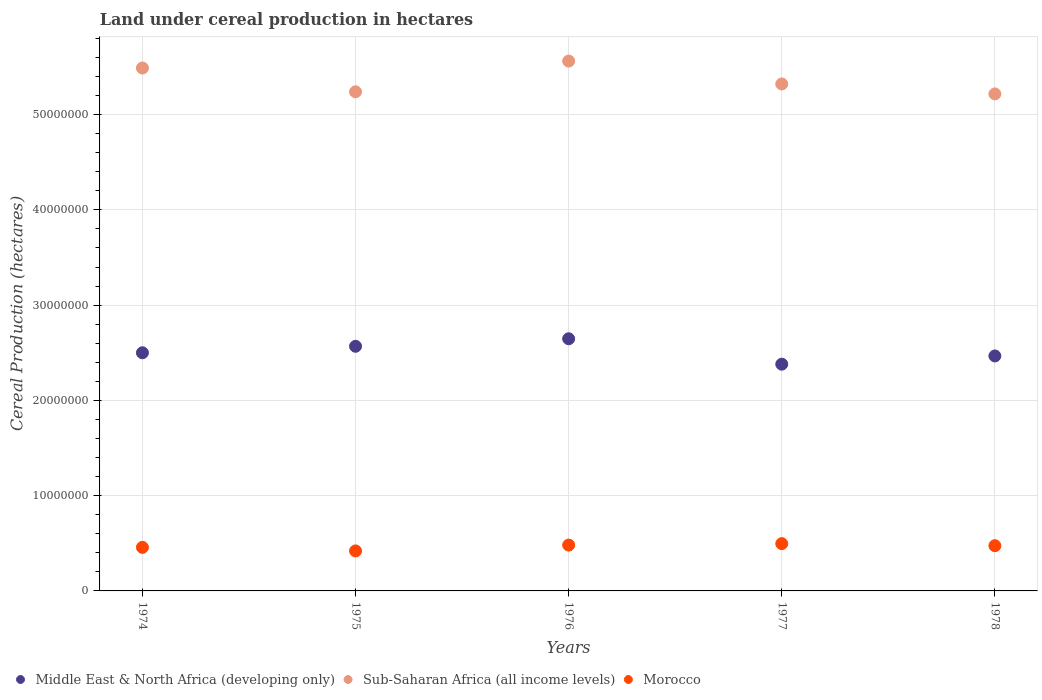What is the land under cereal production in Sub-Saharan Africa (all income levels) in 1975?
Offer a very short reply. 5.24e+07. Across all years, what is the maximum land under cereal production in Morocco?
Your answer should be very brief. 4.96e+06. Across all years, what is the minimum land under cereal production in Sub-Saharan Africa (all income levels)?
Your answer should be very brief. 5.22e+07. In which year was the land under cereal production in Morocco minimum?
Offer a very short reply. 1975. What is the total land under cereal production in Middle East & North Africa (developing only) in the graph?
Your answer should be very brief. 1.26e+08. What is the difference between the land under cereal production in Morocco in 1974 and that in 1978?
Ensure brevity in your answer.  -1.76e+05. What is the difference between the land under cereal production in Sub-Saharan Africa (all income levels) in 1978 and the land under cereal production in Middle East & North Africa (developing only) in 1977?
Give a very brief answer. 2.84e+07. What is the average land under cereal production in Morocco per year?
Offer a terse response. 4.66e+06. In the year 1978, what is the difference between the land under cereal production in Morocco and land under cereal production in Sub-Saharan Africa (all income levels)?
Provide a short and direct response. -4.74e+07. What is the ratio of the land under cereal production in Middle East & North Africa (developing only) in 1975 to that in 1976?
Your answer should be compact. 0.97. Is the land under cereal production in Morocco in 1975 less than that in 1977?
Keep it short and to the point. Yes. Is the difference between the land under cereal production in Morocco in 1976 and 1978 greater than the difference between the land under cereal production in Sub-Saharan Africa (all income levels) in 1976 and 1978?
Your answer should be compact. No. What is the difference between the highest and the second highest land under cereal production in Middle East & North Africa (developing only)?
Your response must be concise. 7.90e+05. What is the difference between the highest and the lowest land under cereal production in Morocco?
Give a very brief answer. 7.63e+05. Does the land under cereal production in Sub-Saharan Africa (all income levels) monotonically increase over the years?
Your response must be concise. No. Is the land under cereal production in Middle East & North Africa (developing only) strictly greater than the land under cereal production in Morocco over the years?
Make the answer very short. Yes. How many dotlines are there?
Provide a succinct answer. 3. What is the difference between two consecutive major ticks on the Y-axis?
Offer a terse response. 1.00e+07. Are the values on the major ticks of Y-axis written in scientific E-notation?
Offer a terse response. No. Where does the legend appear in the graph?
Your answer should be compact. Bottom left. How are the legend labels stacked?
Offer a terse response. Horizontal. What is the title of the graph?
Provide a succinct answer. Land under cereal production in hectares. Does "Korea (Republic)" appear as one of the legend labels in the graph?
Provide a short and direct response. No. What is the label or title of the Y-axis?
Your answer should be very brief. Cereal Production (hectares). What is the Cereal Production (hectares) of Middle East & North Africa (developing only) in 1974?
Provide a succinct answer. 2.50e+07. What is the Cereal Production (hectares) of Sub-Saharan Africa (all income levels) in 1974?
Provide a succinct answer. 5.49e+07. What is the Cereal Production (hectares) in Morocco in 1974?
Offer a very short reply. 4.57e+06. What is the Cereal Production (hectares) of Middle East & North Africa (developing only) in 1975?
Make the answer very short. 2.57e+07. What is the Cereal Production (hectares) of Sub-Saharan Africa (all income levels) in 1975?
Provide a succinct answer. 5.24e+07. What is the Cereal Production (hectares) of Morocco in 1975?
Your response must be concise. 4.20e+06. What is the Cereal Production (hectares) in Middle East & North Africa (developing only) in 1976?
Provide a short and direct response. 2.65e+07. What is the Cereal Production (hectares) in Sub-Saharan Africa (all income levels) in 1976?
Ensure brevity in your answer.  5.56e+07. What is the Cereal Production (hectares) in Morocco in 1976?
Your answer should be very brief. 4.81e+06. What is the Cereal Production (hectares) in Middle East & North Africa (developing only) in 1977?
Provide a succinct answer. 2.38e+07. What is the Cereal Production (hectares) of Sub-Saharan Africa (all income levels) in 1977?
Provide a short and direct response. 5.32e+07. What is the Cereal Production (hectares) in Morocco in 1977?
Keep it short and to the point. 4.96e+06. What is the Cereal Production (hectares) in Middle East & North Africa (developing only) in 1978?
Provide a short and direct response. 2.47e+07. What is the Cereal Production (hectares) in Sub-Saharan Africa (all income levels) in 1978?
Ensure brevity in your answer.  5.22e+07. What is the Cereal Production (hectares) of Morocco in 1978?
Offer a very short reply. 4.75e+06. Across all years, what is the maximum Cereal Production (hectares) of Middle East & North Africa (developing only)?
Offer a terse response. 2.65e+07. Across all years, what is the maximum Cereal Production (hectares) of Sub-Saharan Africa (all income levels)?
Give a very brief answer. 5.56e+07. Across all years, what is the maximum Cereal Production (hectares) of Morocco?
Provide a short and direct response. 4.96e+06. Across all years, what is the minimum Cereal Production (hectares) in Middle East & North Africa (developing only)?
Offer a terse response. 2.38e+07. Across all years, what is the minimum Cereal Production (hectares) in Sub-Saharan Africa (all income levels)?
Your answer should be very brief. 5.22e+07. Across all years, what is the minimum Cereal Production (hectares) of Morocco?
Your answer should be very brief. 4.20e+06. What is the total Cereal Production (hectares) in Middle East & North Africa (developing only) in the graph?
Your answer should be compact. 1.26e+08. What is the total Cereal Production (hectares) of Sub-Saharan Africa (all income levels) in the graph?
Keep it short and to the point. 2.68e+08. What is the total Cereal Production (hectares) of Morocco in the graph?
Your response must be concise. 2.33e+07. What is the difference between the Cereal Production (hectares) of Middle East & North Africa (developing only) in 1974 and that in 1975?
Your response must be concise. -6.79e+05. What is the difference between the Cereal Production (hectares) of Sub-Saharan Africa (all income levels) in 1974 and that in 1975?
Provide a short and direct response. 2.50e+06. What is the difference between the Cereal Production (hectares) in Morocco in 1974 and that in 1975?
Provide a succinct answer. 3.72e+05. What is the difference between the Cereal Production (hectares) of Middle East & North Africa (developing only) in 1974 and that in 1976?
Your response must be concise. -1.47e+06. What is the difference between the Cereal Production (hectares) in Sub-Saharan Africa (all income levels) in 1974 and that in 1976?
Make the answer very short. -7.29e+05. What is the difference between the Cereal Production (hectares) of Morocco in 1974 and that in 1976?
Provide a succinct answer. -2.40e+05. What is the difference between the Cereal Production (hectares) of Middle East & North Africa (developing only) in 1974 and that in 1977?
Your response must be concise. 1.20e+06. What is the difference between the Cereal Production (hectares) of Sub-Saharan Africa (all income levels) in 1974 and that in 1977?
Ensure brevity in your answer.  1.67e+06. What is the difference between the Cereal Production (hectares) in Morocco in 1974 and that in 1977?
Provide a short and direct response. -3.91e+05. What is the difference between the Cereal Production (hectares) in Middle East & North Africa (developing only) in 1974 and that in 1978?
Your answer should be very brief. 3.34e+05. What is the difference between the Cereal Production (hectares) of Sub-Saharan Africa (all income levels) in 1974 and that in 1978?
Offer a very short reply. 2.72e+06. What is the difference between the Cereal Production (hectares) of Morocco in 1974 and that in 1978?
Ensure brevity in your answer.  -1.76e+05. What is the difference between the Cereal Production (hectares) in Middle East & North Africa (developing only) in 1975 and that in 1976?
Keep it short and to the point. -7.90e+05. What is the difference between the Cereal Production (hectares) of Sub-Saharan Africa (all income levels) in 1975 and that in 1976?
Provide a succinct answer. -3.22e+06. What is the difference between the Cereal Production (hectares) of Morocco in 1975 and that in 1976?
Provide a short and direct response. -6.12e+05. What is the difference between the Cereal Production (hectares) in Middle East & North Africa (developing only) in 1975 and that in 1977?
Give a very brief answer. 1.88e+06. What is the difference between the Cereal Production (hectares) in Sub-Saharan Africa (all income levels) in 1975 and that in 1977?
Give a very brief answer. -8.24e+05. What is the difference between the Cereal Production (hectares) of Morocco in 1975 and that in 1977?
Ensure brevity in your answer.  -7.63e+05. What is the difference between the Cereal Production (hectares) in Middle East & North Africa (developing only) in 1975 and that in 1978?
Provide a succinct answer. 1.01e+06. What is the difference between the Cereal Production (hectares) of Sub-Saharan Africa (all income levels) in 1975 and that in 1978?
Keep it short and to the point. 2.23e+05. What is the difference between the Cereal Production (hectares) of Morocco in 1975 and that in 1978?
Your answer should be very brief. -5.48e+05. What is the difference between the Cereal Production (hectares) of Middle East & North Africa (developing only) in 1976 and that in 1977?
Give a very brief answer. 2.67e+06. What is the difference between the Cereal Production (hectares) of Sub-Saharan Africa (all income levels) in 1976 and that in 1977?
Provide a succinct answer. 2.40e+06. What is the difference between the Cereal Production (hectares) in Morocco in 1976 and that in 1977?
Your answer should be very brief. -1.51e+05. What is the difference between the Cereal Production (hectares) in Middle East & North Africa (developing only) in 1976 and that in 1978?
Provide a short and direct response. 1.80e+06. What is the difference between the Cereal Production (hectares) of Sub-Saharan Africa (all income levels) in 1976 and that in 1978?
Offer a very short reply. 3.45e+06. What is the difference between the Cereal Production (hectares) of Morocco in 1976 and that in 1978?
Give a very brief answer. 6.41e+04. What is the difference between the Cereal Production (hectares) of Middle East & North Africa (developing only) in 1977 and that in 1978?
Make the answer very short. -8.64e+05. What is the difference between the Cereal Production (hectares) in Sub-Saharan Africa (all income levels) in 1977 and that in 1978?
Your answer should be compact. 1.05e+06. What is the difference between the Cereal Production (hectares) of Morocco in 1977 and that in 1978?
Provide a succinct answer. 2.16e+05. What is the difference between the Cereal Production (hectares) of Middle East & North Africa (developing only) in 1974 and the Cereal Production (hectares) of Sub-Saharan Africa (all income levels) in 1975?
Keep it short and to the point. -2.74e+07. What is the difference between the Cereal Production (hectares) of Middle East & North Africa (developing only) in 1974 and the Cereal Production (hectares) of Morocco in 1975?
Offer a terse response. 2.08e+07. What is the difference between the Cereal Production (hectares) of Sub-Saharan Africa (all income levels) in 1974 and the Cereal Production (hectares) of Morocco in 1975?
Your answer should be very brief. 5.07e+07. What is the difference between the Cereal Production (hectares) of Middle East & North Africa (developing only) in 1974 and the Cereal Production (hectares) of Sub-Saharan Africa (all income levels) in 1976?
Offer a terse response. -3.06e+07. What is the difference between the Cereal Production (hectares) in Middle East & North Africa (developing only) in 1974 and the Cereal Production (hectares) in Morocco in 1976?
Offer a terse response. 2.02e+07. What is the difference between the Cereal Production (hectares) of Sub-Saharan Africa (all income levels) in 1974 and the Cereal Production (hectares) of Morocco in 1976?
Give a very brief answer. 5.01e+07. What is the difference between the Cereal Production (hectares) of Middle East & North Africa (developing only) in 1974 and the Cereal Production (hectares) of Sub-Saharan Africa (all income levels) in 1977?
Offer a terse response. -2.82e+07. What is the difference between the Cereal Production (hectares) of Middle East & North Africa (developing only) in 1974 and the Cereal Production (hectares) of Morocco in 1977?
Make the answer very short. 2.00e+07. What is the difference between the Cereal Production (hectares) in Sub-Saharan Africa (all income levels) in 1974 and the Cereal Production (hectares) in Morocco in 1977?
Provide a short and direct response. 4.99e+07. What is the difference between the Cereal Production (hectares) of Middle East & North Africa (developing only) in 1974 and the Cereal Production (hectares) of Sub-Saharan Africa (all income levels) in 1978?
Your answer should be very brief. -2.72e+07. What is the difference between the Cereal Production (hectares) in Middle East & North Africa (developing only) in 1974 and the Cereal Production (hectares) in Morocco in 1978?
Give a very brief answer. 2.03e+07. What is the difference between the Cereal Production (hectares) in Sub-Saharan Africa (all income levels) in 1974 and the Cereal Production (hectares) in Morocco in 1978?
Ensure brevity in your answer.  5.01e+07. What is the difference between the Cereal Production (hectares) in Middle East & North Africa (developing only) in 1975 and the Cereal Production (hectares) in Sub-Saharan Africa (all income levels) in 1976?
Provide a short and direct response. -2.99e+07. What is the difference between the Cereal Production (hectares) of Middle East & North Africa (developing only) in 1975 and the Cereal Production (hectares) of Morocco in 1976?
Your answer should be very brief. 2.09e+07. What is the difference between the Cereal Production (hectares) in Sub-Saharan Africa (all income levels) in 1975 and the Cereal Production (hectares) in Morocco in 1976?
Provide a succinct answer. 4.76e+07. What is the difference between the Cereal Production (hectares) of Middle East & North Africa (developing only) in 1975 and the Cereal Production (hectares) of Sub-Saharan Africa (all income levels) in 1977?
Provide a short and direct response. -2.75e+07. What is the difference between the Cereal Production (hectares) of Middle East & North Africa (developing only) in 1975 and the Cereal Production (hectares) of Morocco in 1977?
Provide a succinct answer. 2.07e+07. What is the difference between the Cereal Production (hectares) in Sub-Saharan Africa (all income levels) in 1975 and the Cereal Production (hectares) in Morocco in 1977?
Keep it short and to the point. 4.74e+07. What is the difference between the Cereal Production (hectares) of Middle East & North Africa (developing only) in 1975 and the Cereal Production (hectares) of Sub-Saharan Africa (all income levels) in 1978?
Ensure brevity in your answer.  -2.65e+07. What is the difference between the Cereal Production (hectares) of Middle East & North Africa (developing only) in 1975 and the Cereal Production (hectares) of Morocco in 1978?
Your answer should be compact. 2.09e+07. What is the difference between the Cereal Production (hectares) of Sub-Saharan Africa (all income levels) in 1975 and the Cereal Production (hectares) of Morocco in 1978?
Make the answer very short. 4.76e+07. What is the difference between the Cereal Production (hectares) in Middle East & North Africa (developing only) in 1976 and the Cereal Production (hectares) in Sub-Saharan Africa (all income levels) in 1977?
Give a very brief answer. -2.68e+07. What is the difference between the Cereal Production (hectares) of Middle East & North Africa (developing only) in 1976 and the Cereal Production (hectares) of Morocco in 1977?
Your response must be concise. 2.15e+07. What is the difference between the Cereal Production (hectares) of Sub-Saharan Africa (all income levels) in 1976 and the Cereal Production (hectares) of Morocco in 1977?
Offer a terse response. 5.07e+07. What is the difference between the Cereal Production (hectares) in Middle East & North Africa (developing only) in 1976 and the Cereal Production (hectares) in Sub-Saharan Africa (all income levels) in 1978?
Your response must be concise. -2.57e+07. What is the difference between the Cereal Production (hectares) in Middle East & North Africa (developing only) in 1976 and the Cereal Production (hectares) in Morocco in 1978?
Offer a very short reply. 2.17e+07. What is the difference between the Cereal Production (hectares) of Sub-Saharan Africa (all income levels) in 1976 and the Cereal Production (hectares) of Morocco in 1978?
Your answer should be compact. 5.09e+07. What is the difference between the Cereal Production (hectares) in Middle East & North Africa (developing only) in 1977 and the Cereal Production (hectares) in Sub-Saharan Africa (all income levels) in 1978?
Provide a succinct answer. -2.84e+07. What is the difference between the Cereal Production (hectares) in Middle East & North Africa (developing only) in 1977 and the Cereal Production (hectares) in Morocco in 1978?
Make the answer very short. 1.91e+07. What is the difference between the Cereal Production (hectares) in Sub-Saharan Africa (all income levels) in 1977 and the Cereal Production (hectares) in Morocco in 1978?
Give a very brief answer. 4.85e+07. What is the average Cereal Production (hectares) in Middle East & North Africa (developing only) per year?
Make the answer very short. 2.51e+07. What is the average Cereal Production (hectares) in Sub-Saharan Africa (all income levels) per year?
Your response must be concise. 5.37e+07. What is the average Cereal Production (hectares) of Morocco per year?
Your answer should be very brief. 4.66e+06. In the year 1974, what is the difference between the Cereal Production (hectares) in Middle East & North Africa (developing only) and Cereal Production (hectares) in Sub-Saharan Africa (all income levels)?
Keep it short and to the point. -2.99e+07. In the year 1974, what is the difference between the Cereal Production (hectares) in Middle East & North Africa (developing only) and Cereal Production (hectares) in Morocco?
Your answer should be compact. 2.04e+07. In the year 1974, what is the difference between the Cereal Production (hectares) of Sub-Saharan Africa (all income levels) and Cereal Production (hectares) of Morocco?
Provide a succinct answer. 5.03e+07. In the year 1975, what is the difference between the Cereal Production (hectares) of Middle East & North Africa (developing only) and Cereal Production (hectares) of Sub-Saharan Africa (all income levels)?
Your answer should be very brief. -2.67e+07. In the year 1975, what is the difference between the Cereal Production (hectares) of Middle East & North Africa (developing only) and Cereal Production (hectares) of Morocco?
Make the answer very short. 2.15e+07. In the year 1975, what is the difference between the Cereal Production (hectares) of Sub-Saharan Africa (all income levels) and Cereal Production (hectares) of Morocco?
Offer a terse response. 4.82e+07. In the year 1976, what is the difference between the Cereal Production (hectares) in Middle East & North Africa (developing only) and Cereal Production (hectares) in Sub-Saharan Africa (all income levels)?
Your response must be concise. -2.92e+07. In the year 1976, what is the difference between the Cereal Production (hectares) in Middle East & North Africa (developing only) and Cereal Production (hectares) in Morocco?
Provide a short and direct response. 2.17e+07. In the year 1976, what is the difference between the Cereal Production (hectares) of Sub-Saharan Africa (all income levels) and Cereal Production (hectares) of Morocco?
Ensure brevity in your answer.  5.08e+07. In the year 1977, what is the difference between the Cereal Production (hectares) in Middle East & North Africa (developing only) and Cereal Production (hectares) in Sub-Saharan Africa (all income levels)?
Your answer should be compact. -2.94e+07. In the year 1977, what is the difference between the Cereal Production (hectares) of Middle East & North Africa (developing only) and Cereal Production (hectares) of Morocco?
Your response must be concise. 1.88e+07. In the year 1977, what is the difference between the Cereal Production (hectares) of Sub-Saharan Africa (all income levels) and Cereal Production (hectares) of Morocco?
Your answer should be compact. 4.83e+07. In the year 1978, what is the difference between the Cereal Production (hectares) of Middle East & North Africa (developing only) and Cereal Production (hectares) of Sub-Saharan Africa (all income levels)?
Your answer should be compact. -2.75e+07. In the year 1978, what is the difference between the Cereal Production (hectares) of Middle East & North Africa (developing only) and Cereal Production (hectares) of Morocco?
Your answer should be very brief. 1.99e+07. In the year 1978, what is the difference between the Cereal Production (hectares) of Sub-Saharan Africa (all income levels) and Cereal Production (hectares) of Morocco?
Offer a terse response. 4.74e+07. What is the ratio of the Cereal Production (hectares) in Middle East & North Africa (developing only) in 1974 to that in 1975?
Your response must be concise. 0.97. What is the ratio of the Cereal Production (hectares) in Sub-Saharan Africa (all income levels) in 1974 to that in 1975?
Ensure brevity in your answer.  1.05. What is the ratio of the Cereal Production (hectares) of Morocco in 1974 to that in 1975?
Offer a terse response. 1.09. What is the ratio of the Cereal Production (hectares) in Middle East & North Africa (developing only) in 1974 to that in 1976?
Provide a succinct answer. 0.94. What is the ratio of the Cereal Production (hectares) of Sub-Saharan Africa (all income levels) in 1974 to that in 1976?
Keep it short and to the point. 0.99. What is the ratio of the Cereal Production (hectares) in Morocco in 1974 to that in 1976?
Keep it short and to the point. 0.95. What is the ratio of the Cereal Production (hectares) in Middle East & North Africa (developing only) in 1974 to that in 1977?
Offer a terse response. 1.05. What is the ratio of the Cereal Production (hectares) of Sub-Saharan Africa (all income levels) in 1974 to that in 1977?
Make the answer very short. 1.03. What is the ratio of the Cereal Production (hectares) of Morocco in 1974 to that in 1977?
Offer a terse response. 0.92. What is the ratio of the Cereal Production (hectares) in Middle East & North Africa (developing only) in 1974 to that in 1978?
Provide a succinct answer. 1.01. What is the ratio of the Cereal Production (hectares) in Sub-Saharan Africa (all income levels) in 1974 to that in 1978?
Give a very brief answer. 1.05. What is the ratio of the Cereal Production (hectares) of Middle East & North Africa (developing only) in 1975 to that in 1976?
Offer a very short reply. 0.97. What is the ratio of the Cereal Production (hectares) of Sub-Saharan Africa (all income levels) in 1975 to that in 1976?
Ensure brevity in your answer.  0.94. What is the ratio of the Cereal Production (hectares) of Morocco in 1975 to that in 1976?
Your answer should be very brief. 0.87. What is the ratio of the Cereal Production (hectares) of Middle East & North Africa (developing only) in 1975 to that in 1977?
Your answer should be compact. 1.08. What is the ratio of the Cereal Production (hectares) in Sub-Saharan Africa (all income levels) in 1975 to that in 1977?
Give a very brief answer. 0.98. What is the ratio of the Cereal Production (hectares) in Morocco in 1975 to that in 1977?
Your answer should be compact. 0.85. What is the ratio of the Cereal Production (hectares) of Middle East & North Africa (developing only) in 1975 to that in 1978?
Ensure brevity in your answer.  1.04. What is the ratio of the Cereal Production (hectares) in Sub-Saharan Africa (all income levels) in 1975 to that in 1978?
Provide a succinct answer. 1. What is the ratio of the Cereal Production (hectares) of Morocco in 1975 to that in 1978?
Ensure brevity in your answer.  0.88. What is the ratio of the Cereal Production (hectares) in Middle East & North Africa (developing only) in 1976 to that in 1977?
Your response must be concise. 1.11. What is the ratio of the Cereal Production (hectares) of Sub-Saharan Africa (all income levels) in 1976 to that in 1977?
Your answer should be very brief. 1.05. What is the ratio of the Cereal Production (hectares) of Morocco in 1976 to that in 1977?
Provide a short and direct response. 0.97. What is the ratio of the Cereal Production (hectares) of Middle East & North Africa (developing only) in 1976 to that in 1978?
Your answer should be compact. 1.07. What is the ratio of the Cereal Production (hectares) of Sub-Saharan Africa (all income levels) in 1976 to that in 1978?
Offer a terse response. 1.07. What is the ratio of the Cereal Production (hectares) in Morocco in 1976 to that in 1978?
Ensure brevity in your answer.  1.01. What is the ratio of the Cereal Production (hectares) in Sub-Saharan Africa (all income levels) in 1977 to that in 1978?
Make the answer very short. 1.02. What is the ratio of the Cereal Production (hectares) of Morocco in 1977 to that in 1978?
Offer a very short reply. 1.05. What is the difference between the highest and the second highest Cereal Production (hectares) of Middle East & North Africa (developing only)?
Provide a succinct answer. 7.90e+05. What is the difference between the highest and the second highest Cereal Production (hectares) in Sub-Saharan Africa (all income levels)?
Make the answer very short. 7.29e+05. What is the difference between the highest and the second highest Cereal Production (hectares) in Morocco?
Your response must be concise. 1.51e+05. What is the difference between the highest and the lowest Cereal Production (hectares) of Middle East & North Africa (developing only)?
Your response must be concise. 2.67e+06. What is the difference between the highest and the lowest Cereal Production (hectares) in Sub-Saharan Africa (all income levels)?
Give a very brief answer. 3.45e+06. What is the difference between the highest and the lowest Cereal Production (hectares) in Morocco?
Make the answer very short. 7.63e+05. 